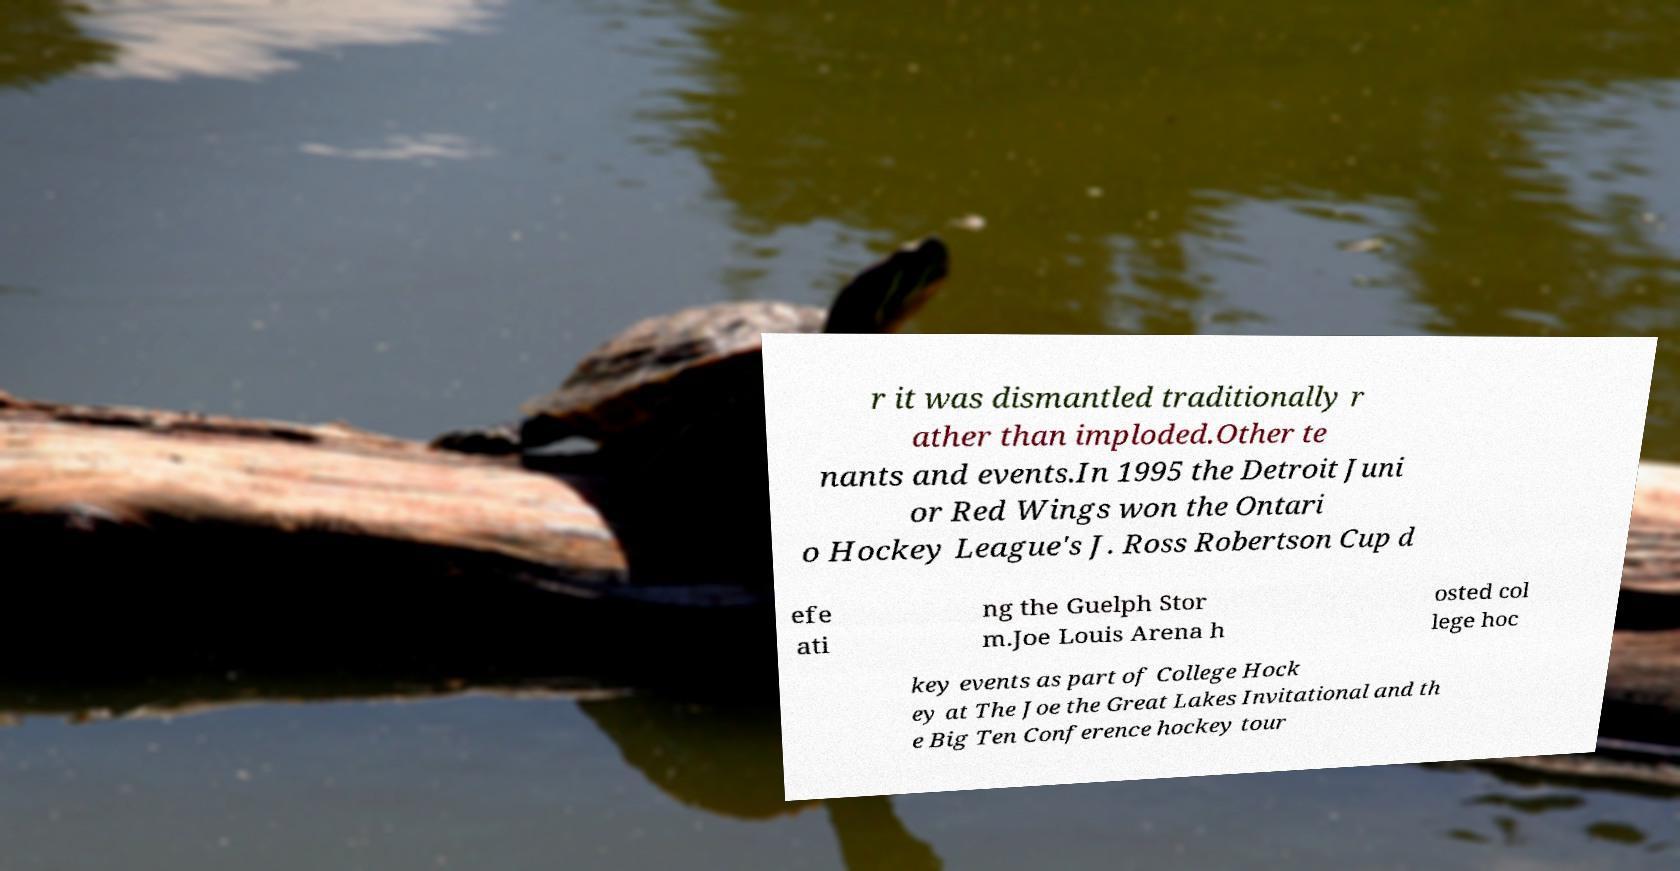Can you accurately transcribe the text from the provided image for me? r it was dismantled traditionally r ather than imploded.Other te nants and events.In 1995 the Detroit Juni or Red Wings won the Ontari o Hockey League's J. Ross Robertson Cup d efe ati ng the Guelph Stor m.Joe Louis Arena h osted col lege hoc key events as part of College Hock ey at The Joe the Great Lakes Invitational and th e Big Ten Conference hockey tour 